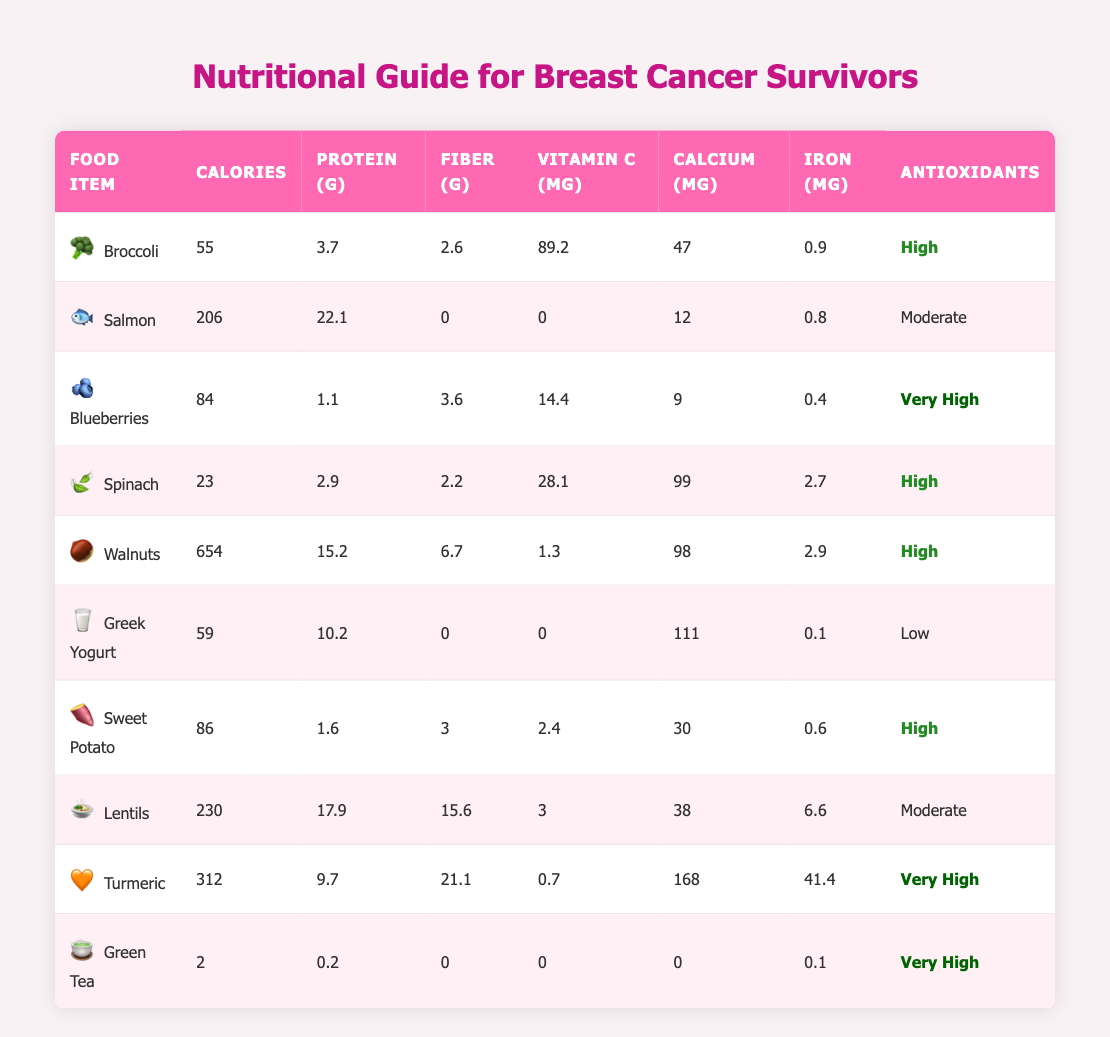What is the calorie content of Salmon? The table shows the specific values for each food item. For Salmon, the calorie content is listed directly in the table as 206.
Answer: 206 Which food item has the highest protein content? By scanning through the protein column of the table, I see that Walnuts have 15.2 grams of protein, the highest among all listed food items.
Answer: Walnuts Do Sweet Potatoes have more fiber than Blueberries? The table lists Sweet Potatoes with 3 grams of fiber and Blueberries with 3.6 grams of fiber. Since 3 is less than 3.6, Sweet Potatoes do not have more fiber.
Answer: No What is the average amount of Vitamin C in the foods listed? To find the average, I need to sum the Vitamin C values: 89.2 + 0 + 14.4 + 28.1 + 1.3 + 0 + 2.4 + 3 + 0.7 + 0 = 139.1 mg. There are 10 food items, so the average is 139.1/10 = 13.91 mg.
Answer: 13.91 mg Are there any foods listed that contain no calories? The table shows all calorie values for each food. The food item Green Tea has a calorie content of 2, meaning it does have calories. Therefore, there are no food items with zero calories in the table.
Answer: No What is the total iron content of Spinach and Lentils combined? Looking at the Iron columns for Spinach (2.7 mg) and Lentils (6.6 mg), I sum these values: 2.7 + 6.6 = 9.3 mg.
Answer: 9.3 mg Which food item provides the most calcium? The Calcium content in the table for each food item shows Greek Yogurt with 111 mg, Spinach with 99 mg, and Turmeric with 168 mg. Turmeric has the highest calcium content.
Answer: Turmeric How many foods have 'Very High' antioxidant content? The table lists the antioxidant content for each food. By counting, Blueberries, Turmeric, and Green Tea are marked as 'Very High.' This gives us a total of 3 foods.
Answer: 3 What is the difference in calories between Walnuts and Greek Yogurt? Walnuts have 654 calories and Greek Yogurt has 59 calories. To find the difference, I subtract: 654 - 59 = 595 calories.
Answer: 595 Is there any food item that has zero protein? The table indicates that Green Tea has 0.2 grams of protein, whereas Salmon has 22.1 grams. Therefore, there are no food items that have zero protein content.
Answer: No 